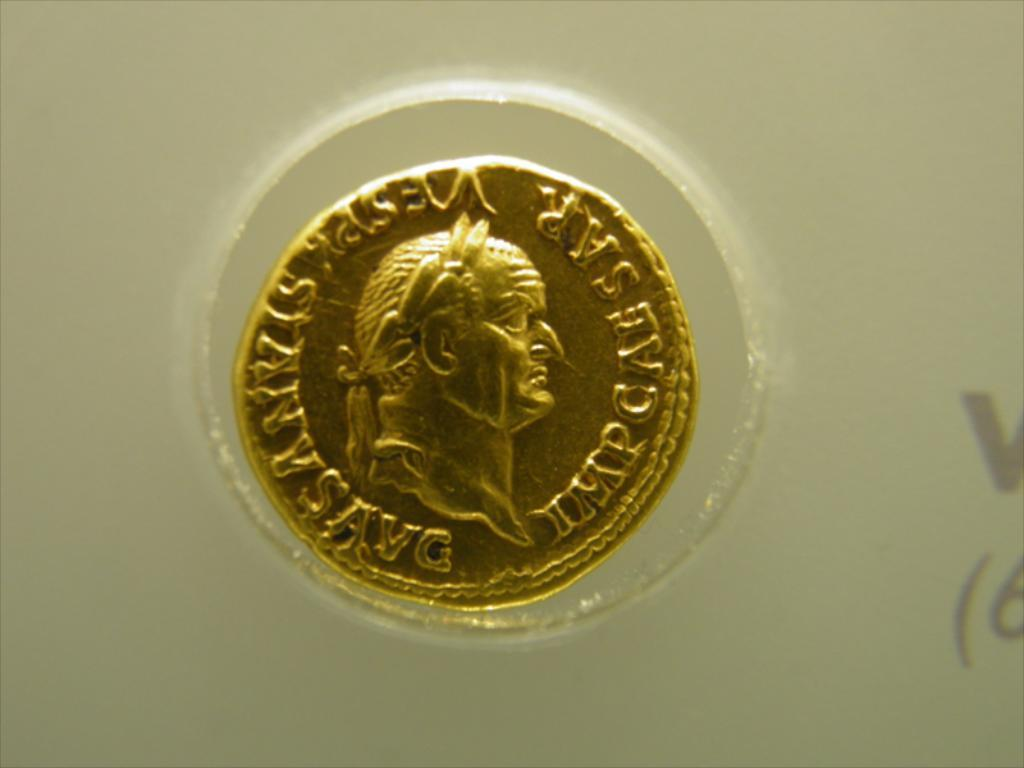Provide a one-sentence caption for the provided image. a gold coin on display with a person's profile and words SAR. 